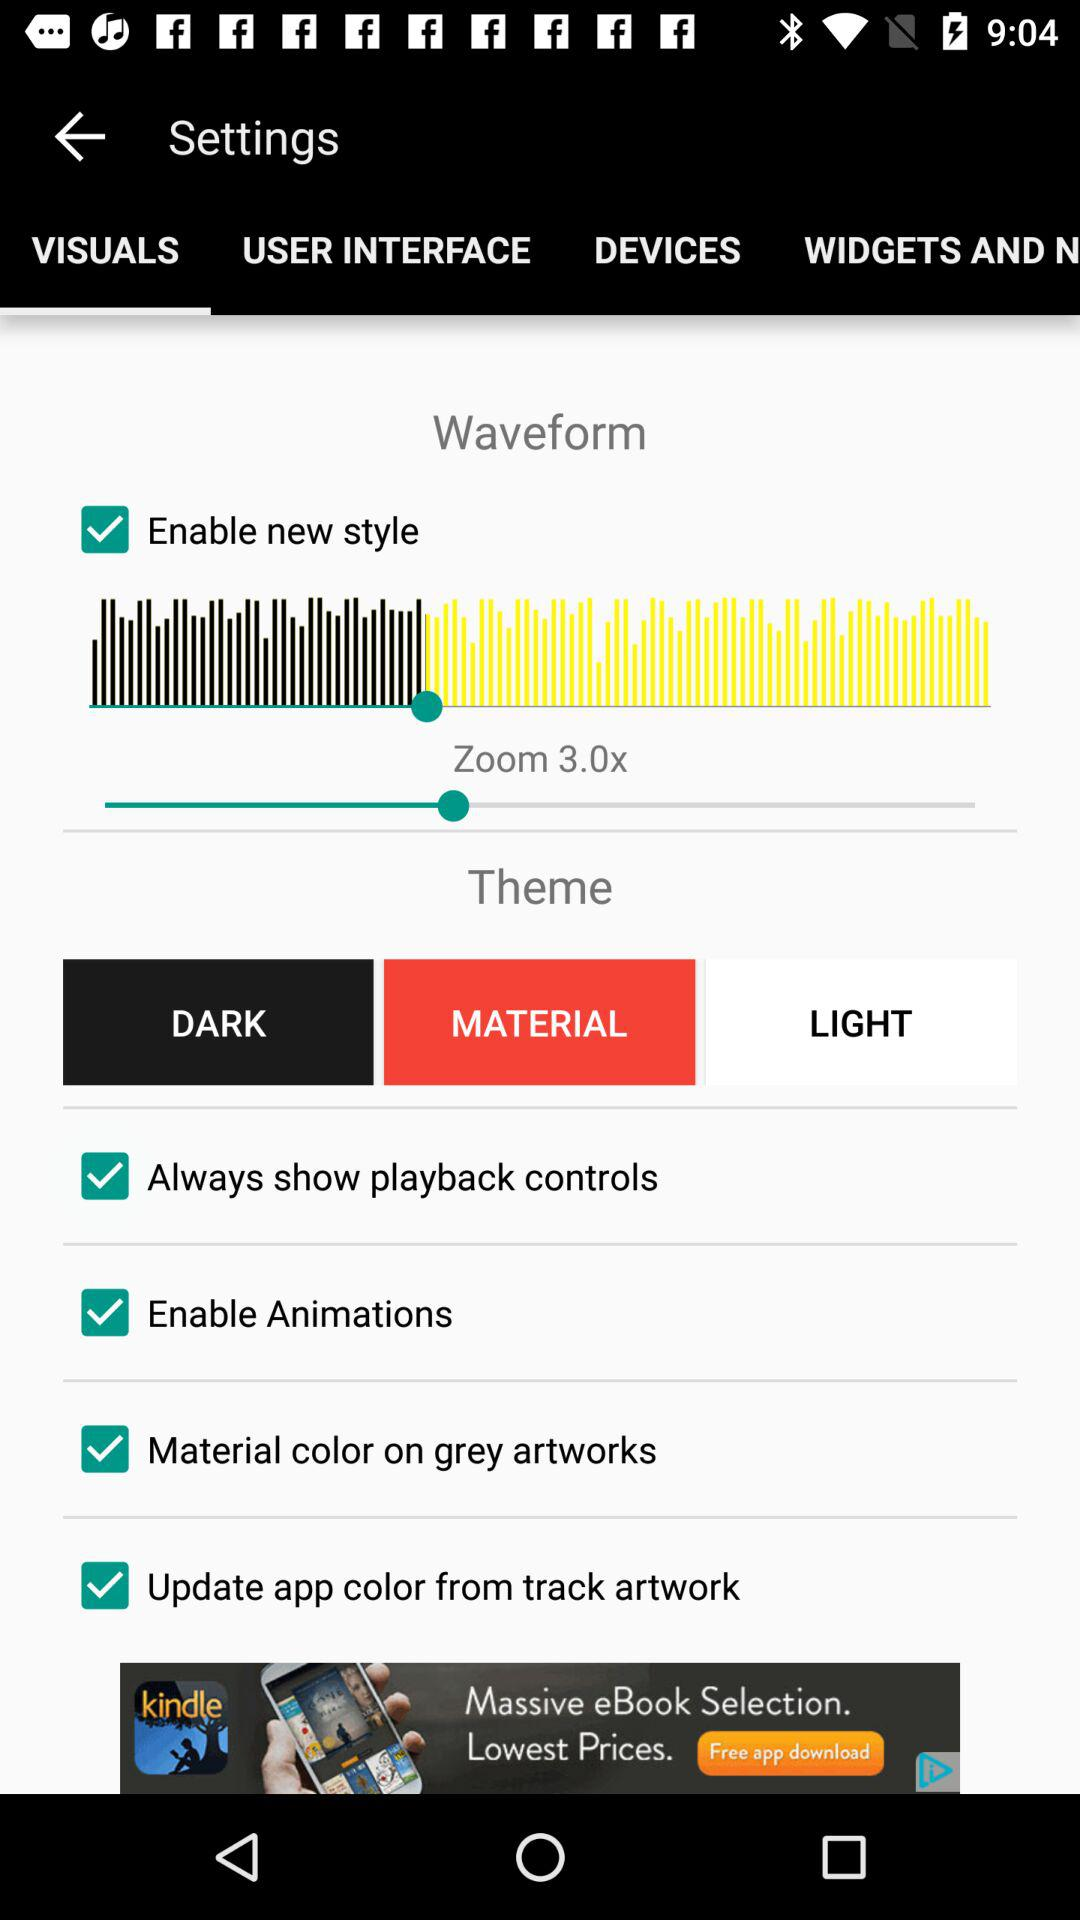Which is the selected tab? The selected tab is "VISUALS". 